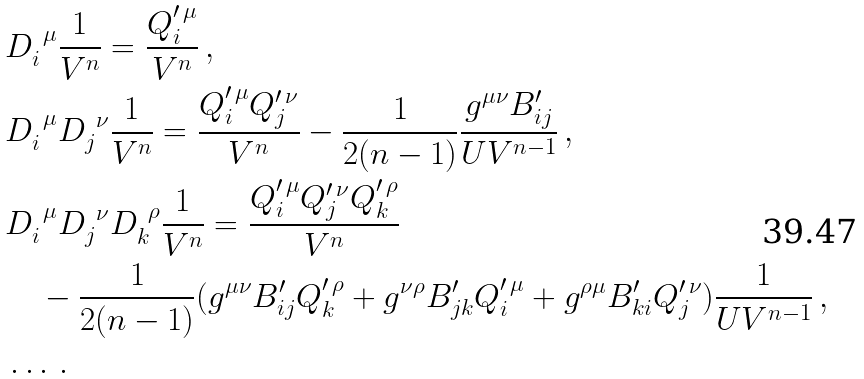<formula> <loc_0><loc_0><loc_500><loc_500>& D _ { i } ^ { \ \mu } \frac { 1 } { V ^ { n } } = \frac { Q ^ { \prime \, \mu } _ { i } } { V ^ { n } } \, , \\ & D _ { i } ^ { \ \mu } D _ { j } ^ { \ \nu } \frac { 1 } { V ^ { n } } = \frac { Q ^ { \prime \, \mu } _ { i } Q ^ { \prime \, \nu } _ { j } } { V ^ { n } } - \frac { 1 } { 2 ( n - 1 ) } \frac { g ^ { \mu \nu } B ^ { \prime } _ { i j } } { U V ^ { n - 1 } } \, , \\ & D _ { i } ^ { \ \mu } D _ { j } ^ { \ \nu } D _ { k } ^ { \ \rho } \frac { 1 } { V ^ { n } } = \frac { Q ^ { \prime \, \mu } _ { i } Q ^ { \prime \, \nu } _ { j } Q ^ { \prime \, \rho } _ { k } } { V ^ { n } } \\ & \quad - \frac { 1 } { 2 ( n - 1 ) } ( g ^ { \mu \nu } B ^ { \prime } _ { i j } Q ^ { \prime \, \rho } _ { k } + g ^ { \nu \rho } B ^ { \prime } _ { j k } Q ^ { \prime \, \mu } _ { i } + g ^ { \rho \mu } B ^ { \prime } _ { k i } Q ^ { \prime \, \nu } _ { j } ) \frac { 1 } { U V ^ { n - 1 } } \, , \\ & \dots \, .</formula> 